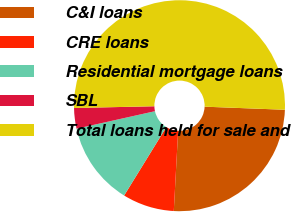Convert chart. <chart><loc_0><loc_0><loc_500><loc_500><pie_chart><fcel>C&I loans<fcel>CRE loans<fcel>Residential mortgage loans<fcel>SBL<fcel>Total loans held for sale and<nl><fcel>25.25%<fcel>7.93%<fcel>12.71%<fcel>3.15%<fcel>50.95%<nl></chart> 